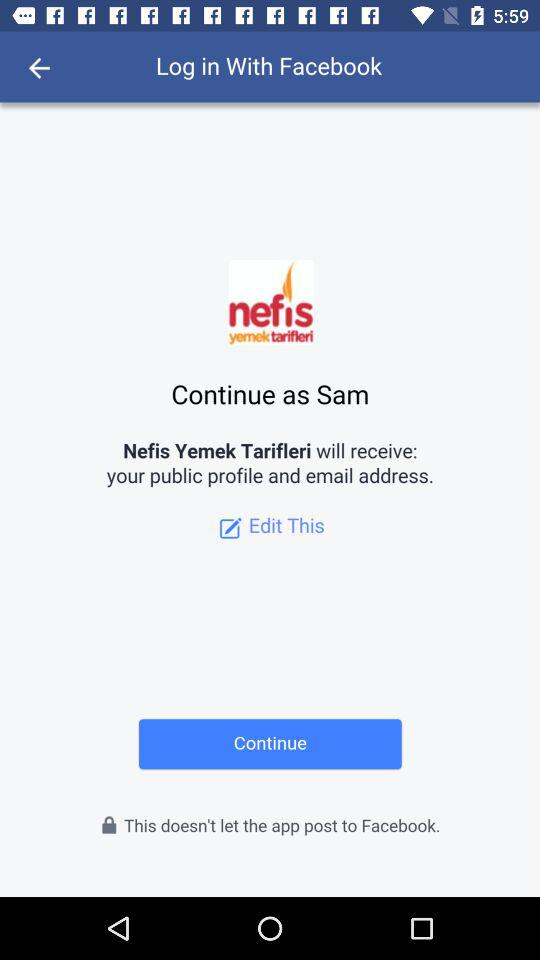What is the name of the user? The name of the user is Sam. 